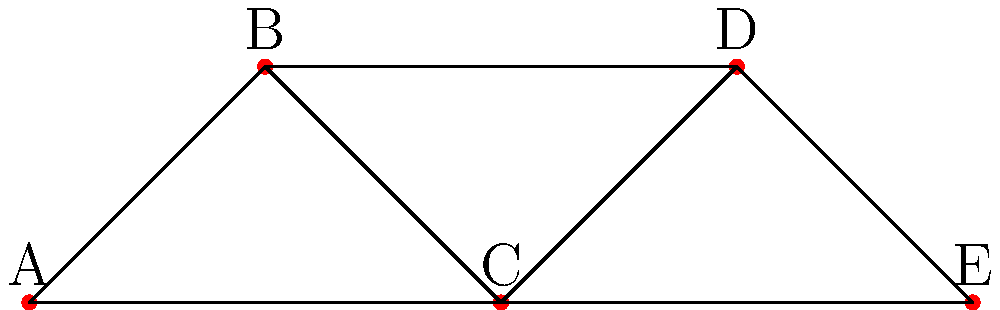In this social network diagram representing connections among colonial women, which woman has the highest degree centrality? Explain your reasoning using graph theory concepts. To determine the woman with the highest degree centrality, we need to follow these steps:

1. Understand degree centrality: In graph theory, degree centrality is a measure of a node's connectedness, calculated by counting the number of edges connected to that node.

2. Count connections for each node:
   A: 2 connections (to B and C)
   B: 3 connections (to A, C, and D)
   C: 4 connections (to A, B, D, and E)
   D: 3 connections (to B, C, and E)
   E: 2 connections (to C and D)

3. Compare the counts:
   C has the highest number of connections with 4.

4. Interpret the result: In this social network of colonial women, woman C has the most direct connections to other women, indicating she likely plays a central role in information exchange and social influence within this group.

Therefore, woman C has the highest degree centrality in this social network.
Answer: C 